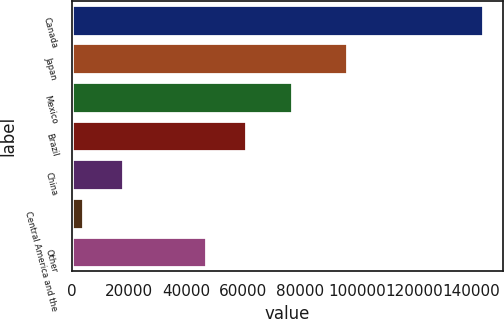<chart> <loc_0><loc_0><loc_500><loc_500><bar_chart><fcel>Canada<fcel>Japan<fcel>Mexico<fcel>Brazil<fcel>China<fcel>Central America and the<fcel>Other<nl><fcel>144154<fcel>96543<fcel>77104<fcel>60949.9<fcel>17929.9<fcel>3905<fcel>46925<nl></chart> 